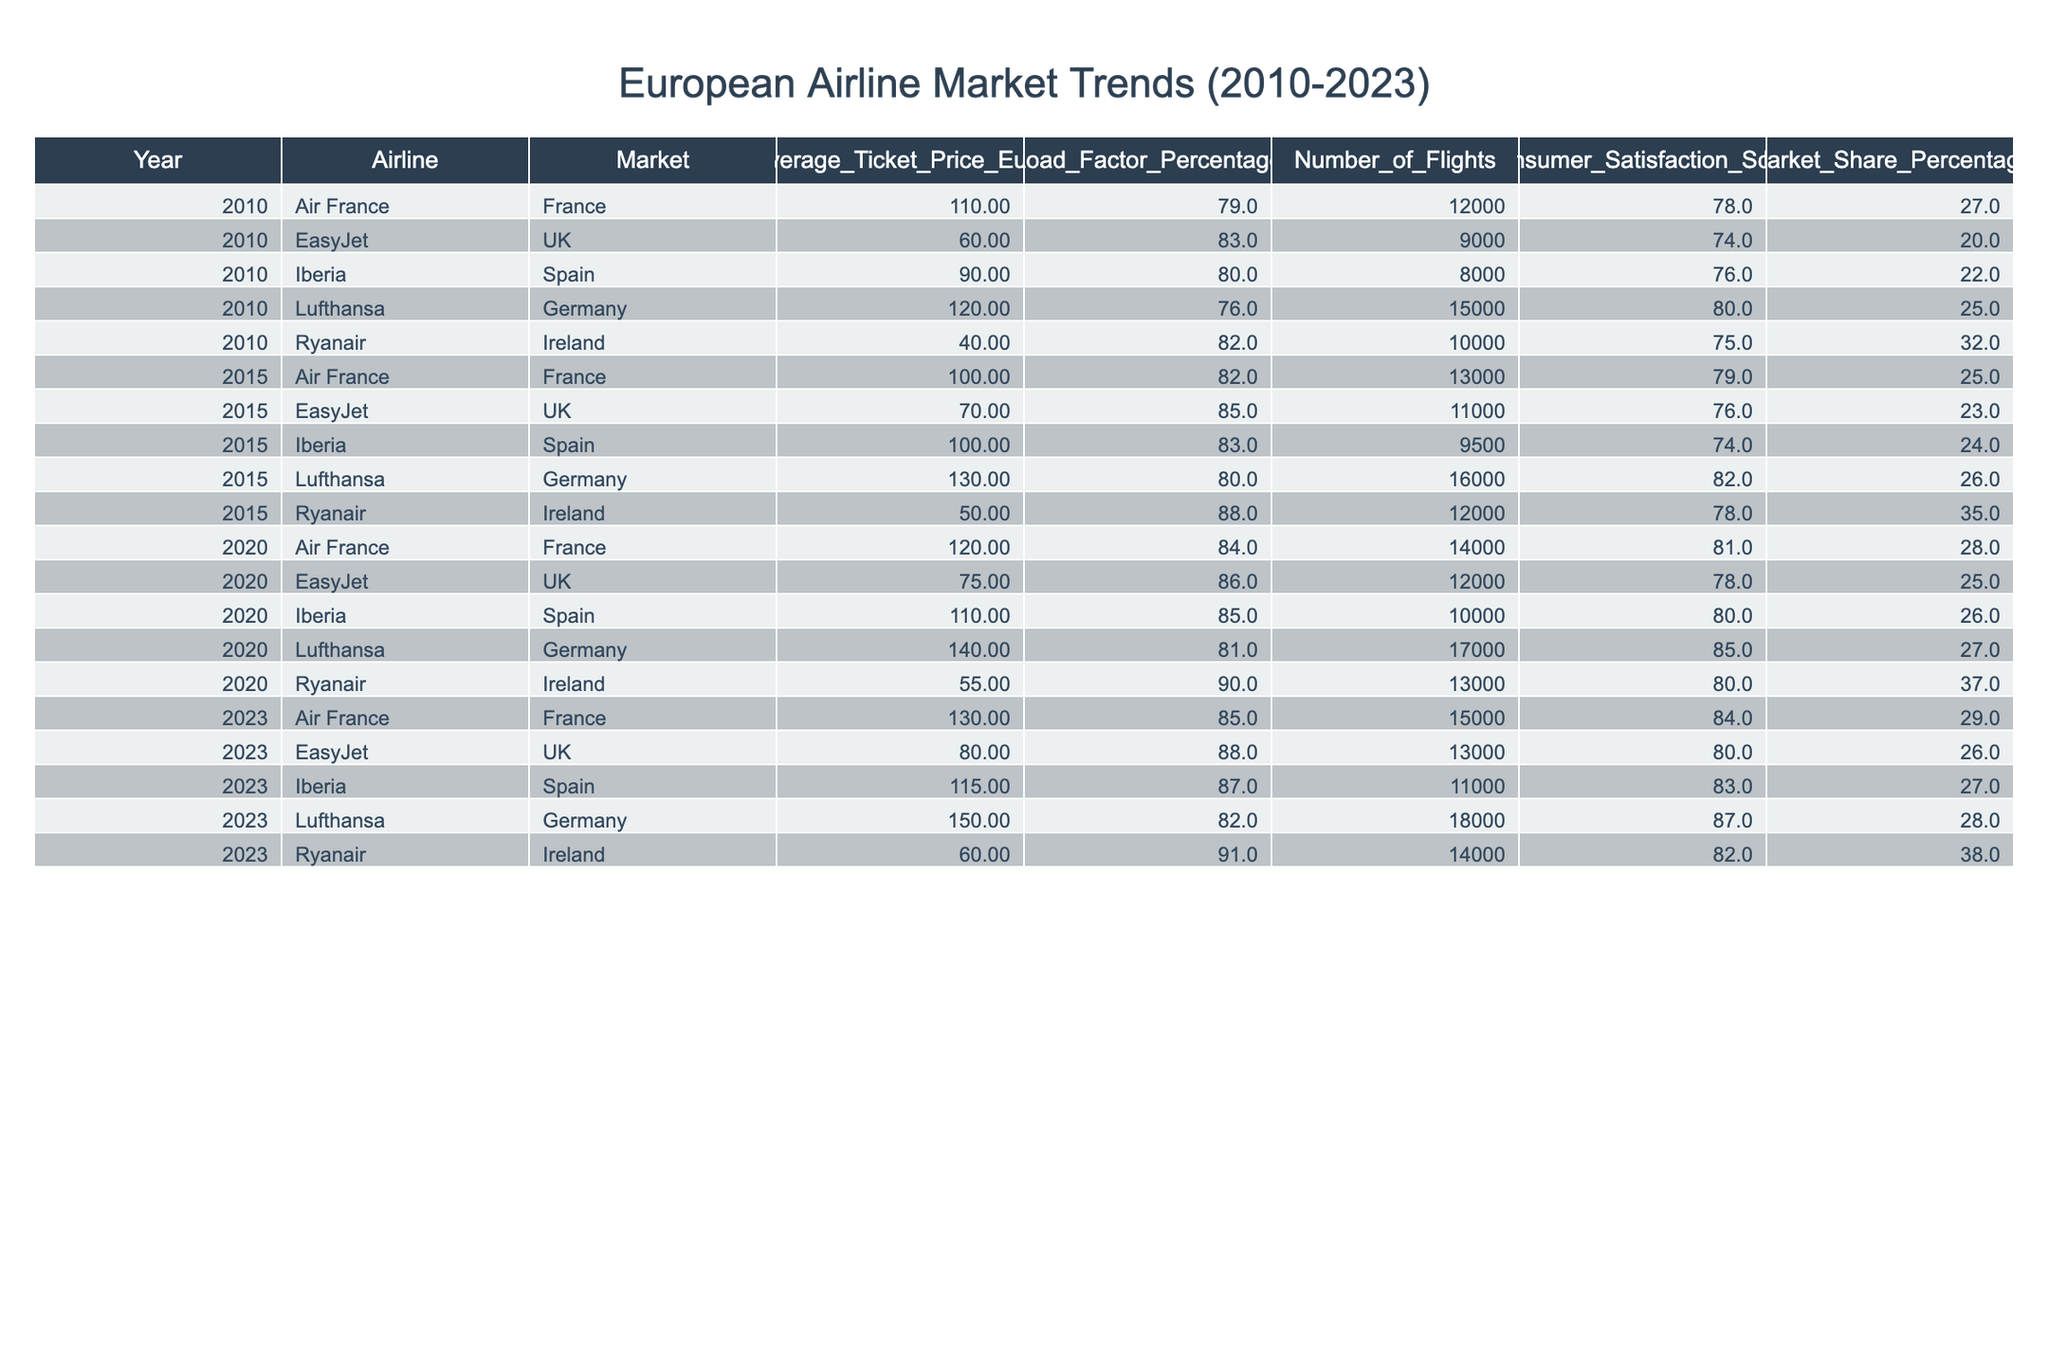What was the average ticket price for Ryanair in 2020? In 2020, the table shows that the average ticket price for Ryanair in Ireland was 55 Euro.
Answer: 55 Euro Which airline had the highest load factor in 2015? In 2015, Ryanair had a load factor of 88%, which is the highest compared to other airlines in that year.
Answer: Ryanair How many flights did Lufthansa operate in 2023? The table indicates that Lufthansa operated 18,000 flights in 2023.
Answer: 18,000 flights What was the change in average ticket price for Air France between 2010 and 2023? Air France's average ticket price increased from 110 Euro in 2010 to 130 Euro in 2023. The difference is 130 - 110 = 20 Euro.
Answer: 20 Euro increase Which airline consistently maintained a market share percentage above 25% over the years? Analyzing the market share percentages: Ryanair maintained 32, 35, 37, and 38% respectively over the years, consistently above 25%.
Answer: Ryanair What is the consumer satisfaction score for EasyJet in 2015? The table shows EasyJet had a consumer satisfaction score of 76 in 2015.
Answer: 76 Did Iberia's average ticket price increase every year from 2010 to 2023? The average ticket prices for Iberia were 90 Euro in 2010, 100 Euro in 2015, 110 Euro in 2020, and then 115 Euro in 2023, showing a consistent increase.
Answer: Yes What was the average ticket price across all airlines in 2020? To find the average ticket price in 2020, add Ryanair (55), Lufthansa (140), Air France (120), EasyJet (75), and Iberia (110) which sums to 500 Euro. Dividing by the 5 airlines gives an average of 500/5 = 100 Euro.
Answer: 100 Euro Which market had the highest average ticket price in 2023? In 2023, Lufthansa had the highest average ticket price of 150 Euro compared to other airlines shown in the table.
Answer: Lufthansa What is the trend in the load factor for EasyJet from 2010 to 2023? EasyJet's load factors were 83% (2010), 85% (2015), 86% (2020), and 88% (2023). This indicates an increasing trend over the years.
Answer: Increasing trend What would be the total number of flights from all airlines in 2010? The total number of flights operated in 2010 can be calculated by adding the number of flights for all airlines: 10,000 (Ryanair) + 15,000 (Lufthansa) + 12,000 (Air France) + 9,000 (EasyJet) + 8,000 (Iberia) = 54,000 flights.
Answer: 54,000 flights 